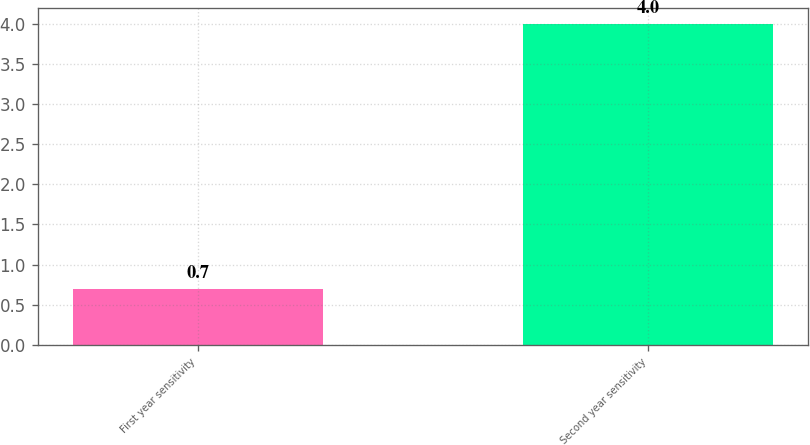<chart> <loc_0><loc_0><loc_500><loc_500><bar_chart><fcel>First year sensitivity<fcel>Second year sensitivity<nl><fcel>0.7<fcel>4<nl></chart> 